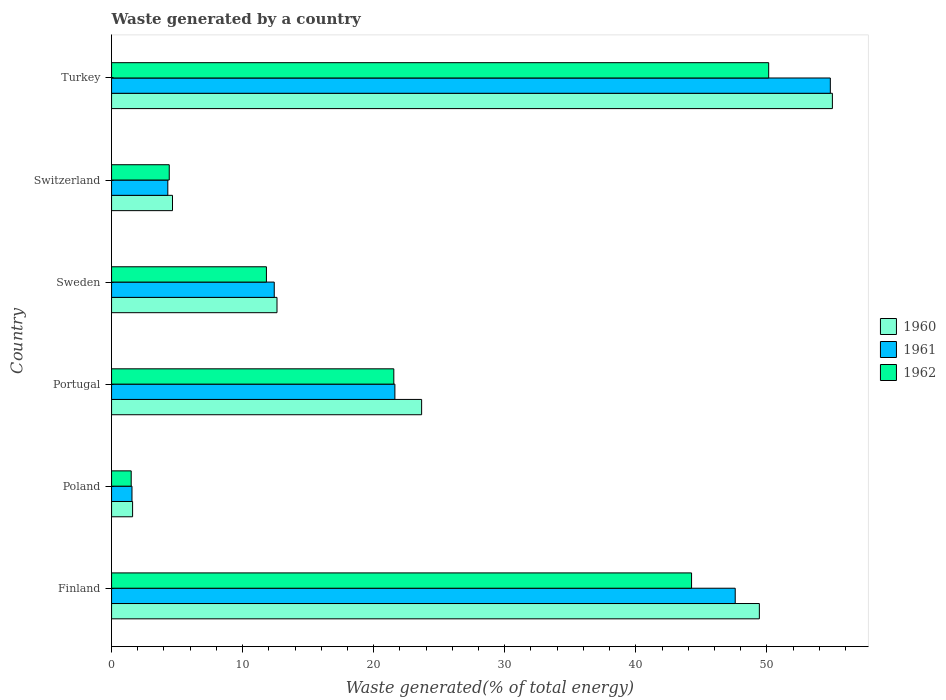How many groups of bars are there?
Offer a terse response. 6. Are the number of bars on each tick of the Y-axis equal?
Your response must be concise. Yes. How many bars are there on the 1st tick from the top?
Provide a short and direct response. 3. What is the label of the 2nd group of bars from the top?
Offer a terse response. Switzerland. In how many cases, is the number of bars for a given country not equal to the number of legend labels?
Provide a short and direct response. 0. What is the total waste generated in 1961 in Portugal?
Your response must be concise. 21.62. Across all countries, what is the maximum total waste generated in 1961?
Your response must be concise. 54.84. Across all countries, what is the minimum total waste generated in 1962?
Provide a short and direct response. 1.5. In which country was the total waste generated in 1962 maximum?
Make the answer very short. Turkey. In which country was the total waste generated in 1962 minimum?
Give a very brief answer. Poland. What is the total total waste generated in 1961 in the graph?
Provide a succinct answer. 142.3. What is the difference between the total waste generated in 1960 in Poland and that in Sweden?
Provide a succinct answer. -11.02. What is the difference between the total waste generated in 1960 in Turkey and the total waste generated in 1961 in Switzerland?
Your response must be concise. 50.7. What is the average total waste generated in 1962 per country?
Make the answer very short. 22.27. What is the difference between the total waste generated in 1961 and total waste generated in 1962 in Turkey?
Offer a terse response. 4.7. In how many countries, is the total waste generated in 1962 greater than 42 %?
Your response must be concise. 2. What is the ratio of the total waste generated in 1962 in Poland to that in Turkey?
Make the answer very short. 0.03. Is the difference between the total waste generated in 1961 in Switzerland and Turkey greater than the difference between the total waste generated in 1962 in Switzerland and Turkey?
Your response must be concise. No. What is the difference between the highest and the second highest total waste generated in 1960?
Your answer should be compact. 5.57. What is the difference between the highest and the lowest total waste generated in 1960?
Offer a terse response. 53.39. In how many countries, is the total waste generated in 1961 greater than the average total waste generated in 1961 taken over all countries?
Ensure brevity in your answer.  2. What does the 2nd bar from the top in Poland represents?
Offer a very short reply. 1961. What does the 3rd bar from the bottom in Portugal represents?
Your answer should be compact. 1962. Is it the case that in every country, the sum of the total waste generated in 1962 and total waste generated in 1961 is greater than the total waste generated in 1960?
Make the answer very short. Yes. Are all the bars in the graph horizontal?
Offer a very short reply. Yes. How many countries are there in the graph?
Provide a short and direct response. 6. What is the difference between two consecutive major ticks on the X-axis?
Provide a short and direct response. 10. Does the graph contain grids?
Give a very brief answer. No. Where does the legend appear in the graph?
Offer a very short reply. Center right. How many legend labels are there?
Offer a very short reply. 3. How are the legend labels stacked?
Keep it short and to the point. Vertical. What is the title of the graph?
Provide a succinct answer. Waste generated by a country. What is the label or title of the X-axis?
Your response must be concise. Waste generated(% of total energy). What is the label or title of the Y-axis?
Provide a succinct answer. Country. What is the Waste generated(% of total energy) of 1960 in Finland?
Offer a very short reply. 49.42. What is the Waste generated(% of total energy) in 1961 in Finland?
Keep it short and to the point. 47.58. What is the Waste generated(% of total energy) of 1962 in Finland?
Your answer should be compact. 44.25. What is the Waste generated(% of total energy) in 1960 in Poland?
Give a very brief answer. 1.6. What is the Waste generated(% of total energy) in 1961 in Poland?
Ensure brevity in your answer.  1.56. What is the Waste generated(% of total energy) in 1962 in Poland?
Your answer should be very brief. 1.5. What is the Waste generated(% of total energy) in 1960 in Portugal?
Provide a short and direct response. 23.66. What is the Waste generated(% of total energy) in 1961 in Portugal?
Offer a terse response. 21.62. What is the Waste generated(% of total energy) in 1962 in Portugal?
Your response must be concise. 21.53. What is the Waste generated(% of total energy) of 1960 in Sweden?
Ensure brevity in your answer.  12.62. What is the Waste generated(% of total energy) of 1961 in Sweden?
Offer a very short reply. 12.41. What is the Waste generated(% of total energy) in 1962 in Sweden?
Offer a very short reply. 11.82. What is the Waste generated(% of total energy) in 1960 in Switzerland?
Your answer should be very brief. 4.65. What is the Waste generated(% of total energy) of 1961 in Switzerland?
Your answer should be compact. 4.29. What is the Waste generated(% of total energy) of 1962 in Switzerland?
Your response must be concise. 4.4. What is the Waste generated(% of total energy) in 1960 in Turkey?
Ensure brevity in your answer.  54.99. What is the Waste generated(% of total energy) of 1961 in Turkey?
Make the answer very short. 54.84. What is the Waste generated(% of total energy) in 1962 in Turkey?
Your answer should be compact. 50.13. Across all countries, what is the maximum Waste generated(% of total energy) in 1960?
Offer a terse response. 54.99. Across all countries, what is the maximum Waste generated(% of total energy) of 1961?
Keep it short and to the point. 54.84. Across all countries, what is the maximum Waste generated(% of total energy) in 1962?
Keep it short and to the point. 50.13. Across all countries, what is the minimum Waste generated(% of total energy) of 1960?
Your response must be concise. 1.6. Across all countries, what is the minimum Waste generated(% of total energy) of 1961?
Keep it short and to the point. 1.56. Across all countries, what is the minimum Waste generated(% of total energy) in 1962?
Offer a very short reply. 1.5. What is the total Waste generated(% of total energy) of 1960 in the graph?
Ensure brevity in your answer.  146.95. What is the total Waste generated(% of total energy) of 1961 in the graph?
Your answer should be very brief. 142.3. What is the total Waste generated(% of total energy) in 1962 in the graph?
Your answer should be very brief. 133.64. What is the difference between the Waste generated(% of total energy) in 1960 in Finland and that in Poland?
Give a very brief answer. 47.82. What is the difference between the Waste generated(% of total energy) of 1961 in Finland and that in Poland?
Keep it short and to the point. 46.02. What is the difference between the Waste generated(% of total energy) of 1962 in Finland and that in Poland?
Provide a short and direct response. 42.75. What is the difference between the Waste generated(% of total energy) of 1960 in Finland and that in Portugal?
Keep it short and to the point. 25.77. What is the difference between the Waste generated(% of total energy) in 1961 in Finland and that in Portugal?
Your response must be concise. 25.96. What is the difference between the Waste generated(% of total energy) in 1962 in Finland and that in Portugal?
Ensure brevity in your answer.  22.72. What is the difference between the Waste generated(% of total energy) in 1960 in Finland and that in Sweden?
Provide a short and direct response. 36.8. What is the difference between the Waste generated(% of total energy) in 1961 in Finland and that in Sweden?
Offer a terse response. 35.17. What is the difference between the Waste generated(% of total energy) in 1962 in Finland and that in Sweden?
Give a very brief answer. 32.44. What is the difference between the Waste generated(% of total energy) in 1960 in Finland and that in Switzerland?
Make the answer very short. 44.77. What is the difference between the Waste generated(% of total energy) of 1961 in Finland and that in Switzerland?
Your answer should be very brief. 43.29. What is the difference between the Waste generated(% of total energy) in 1962 in Finland and that in Switzerland?
Provide a succinct answer. 39.85. What is the difference between the Waste generated(% of total energy) in 1960 in Finland and that in Turkey?
Make the answer very short. -5.57. What is the difference between the Waste generated(% of total energy) in 1961 in Finland and that in Turkey?
Offer a very short reply. -7.26. What is the difference between the Waste generated(% of total energy) of 1962 in Finland and that in Turkey?
Offer a terse response. -5.88. What is the difference between the Waste generated(% of total energy) of 1960 in Poland and that in Portugal?
Offer a terse response. -22.05. What is the difference between the Waste generated(% of total energy) of 1961 in Poland and that in Portugal?
Your answer should be very brief. -20.06. What is the difference between the Waste generated(% of total energy) of 1962 in Poland and that in Portugal?
Keep it short and to the point. -20.03. What is the difference between the Waste generated(% of total energy) of 1960 in Poland and that in Sweden?
Keep it short and to the point. -11.02. What is the difference between the Waste generated(% of total energy) of 1961 in Poland and that in Sweden?
Provide a succinct answer. -10.85. What is the difference between the Waste generated(% of total energy) in 1962 in Poland and that in Sweden?
Ensure brevity in your answer.  -10.32. What is the difference between the Waste generated(% of total energy) of 1960 in Poland and that in Switzerland?
Give a very brief answer. -3.04. What is the difference between the Waste generated(% of total energy) in 1961 in Poland and that in Switzerland?
Your answer should be very brief. -2.73. What is the difference between the Waste generated(% of total energy) of 1962 in Poland and that in Switzerland?
Give a very brief answer. -2.9. What is the difference between the Waste generated(% of total energy) of 1960 in Poland and that in Turkey?
Your answer should be compact. -53.39. What is the difference between the Waste generated(% of total energy) in 1961 in Poland and that in Turkey?
Your response must be concise. -53.28. What is the difference between the Waste generated(% of total energy) of 1962 in Poland and that in Turkey?
Make the answer very short. -48.64. What is the difference between the Waste generated(% of total energy) in 1960 in Portugal and that in Sweden?
Make the answer very short. 11.03. What is the difference between the Waste generated(% of total energy) in 1961 in Portugal and that in Sweden?
Your answer should be very brief. 9.2. What is the difference between the Waste generated(% of total energy) in 1962 in Portugal and that in Sweden?
Offer a very short reply. 9.72. What is the difference between the Waste generated(% of total energy) of 1960 in Portugal and that in Switzerland?
Your answer should be very brief. 19.01. What is the difference between the Waste generated(% of total energy) in 1961 in Portugal and that in Switzerland?
Provide a succinct answer. 17.32. What is the difference between the Waste generated(% of total energy) of 1962 in Portugal and that in Switzerland?
Ensure brevity in your answer.  17.13. What is the difference between the Waste generated(% of total energy) of 1960 in Portugal and that in Turkey?
Provide a short and direct response. -31.34. What is the difference between the Waste generated(% of total energy) of 1961 in Portugal and that in Turkey?
Offer a very short reply. -33.22. What is the difference between the Waste generated(% of total energy) in 1962 in Portugal and that in Turkey?
Your response must be concise. -28.6. What is the difference between the Waste generated(% of total energy) of 1960 in Sweden and that in Switzerland?
Give a very brief answer. 7.97. What is the difference between the Waste generated(% of total energy) in 1961 in Sweden and that in Switzerland?
Ensure brevity in your answer.  8.12. What is the difference between the Waste generated(% of total energy) of 1962 in Sweden and that in Switzerland?
Your response must be concise. 7.41. What is the difference between the Waste generated(% of total energy) in 1960 in Sweden and that in Turkey?
Your answer should be very brief. -42.37. What is the difference between the Waste generated(% of total energy) in 1961 in Sweden and that in Turkey?
Offer a terse response. -42.43. What is the difference between the Waste generated(% of total energy) in 1962 in Sweden and that in Turkey?
Your answer should be very brief. -38.32. What is the difference between the Waste generated(% of total energy) in 1960 in Switzerland and that in Turkey?
Ensure brevity in your answer.  -50.34. What is the difference between the Waste generated(% of total energy) in 1961 in Switzerland and that in Turkey?
Provide a short and direct response. -50.55. What is the difference between the Waste generated(% of total energy) in 1962 in Switzerland and that in Turkey?
Offer a terse response. -45.73. What is the difference between the Waste generated(% of total energy) in 1960 in Finland and the Waste generated(% of total energy) in 1961 in Poland?
Your response must be concise. 47.86. What is the difference between the Waste generated(% of total energy) in 1960 in Finland and the Waste generated(% of total energy) in 1962 in Poland?
Your answer should be very brief. 47.92. What is the difference between the Waste generated(% of total energy) in 1961 in Finland and the Waste generated(% of total energy) in 1962 in Poland?
Ensure brevity in your answer.  46.08. What is the difference between the Waste generated(% of total energy) of 1960 in Finland and the Waste generated(% of total energy) of 1961 in Portugal?
Your answer should be very brief. 27.81. What is the difference between the Waste generated(% of total energy) of 1960 in Finland and the Waste generated(% of total energy) of 1962 in Portugal?
Ensure brevity in your answer.  27.89. What is the difference between the Waste generated(% of total energy) of 1961 in Finland and the Waste generated(% of total energy) of 1962 in Portugal?
Your answer should be very brief. 26.05. What is the difference between the Waste generated(% of total energy) of 1960 in Finland and the Waste generated(% of total energy) of 1961 in Sweden?
Your answer should be compact. 37.01. What is the difference between the Waste generated(% of total energy) in 1960 in Finland and the Waste generated(% of total energy) in 1962 in Sweden?
Give a very brief answer. 37.61. What is the difference between the Waste generated(% of total energy) in 1961 in Finland and the Waste generated(% of total energy) in 1962 in Sweden?
Provide a short and direct response. 35.77. What is the difference between the Waste generated(% of total energy) of 1960 in Finland and the Waste generated(% of total energy) of 1961 in Switzerland?
Give a very brief answer. 45.13. What is the difference between the Waste generated(% of total energy) in 1960 in Finland and the Waste generated(% of total energy) in 1962 in Switzerland?
Offer a terse response. 45.02. What is the difference between the Waste generated(% of total energy) of 1961 in Finland and the Waste generated(% of total energy) of 1962 in Switzerland?
Your answer should be very brief. 43.18. What is the difference between the Waste generated(% of total energy) in 1960 in Finland and the Waste generated(% of total energy) in 1961 in Turkey?
Your answer should be very brief. -5.42. What is the difference between the Waste generated(% of total energy) in 1960 in Finland and the Waste generated(% of total energy) in 1962 in Turkey?
Keep it short and to the point. -0.71. What is the difference between the Waste generated(% of total energy) of 1961 in Finland and the Waste generated(% of total energy) of 1962 in Turkey?
Give a very brief answer. -2.55. What is the difference between the Waste generated(% of total energy) in 1960 in Poland and the Waste generated(% of total energy) in 1961 in Portugal?
Your response must be concise. -20.01. What is the difference between the Waste generated(% of total energy) of 1960 in Poland and the Waste generated(% of total energy) of 1962 in Portugal?
Make the answer very short. -19.93. What is the difference between the Waste generated(% of total energy) in 1961 in Poland and the Waste generated(% of total energy) in 1962 in Portugal?
Offer a very short reply. -19.98. What is the difference between the Waste generated(% of total energy) in 1960 in Poland and the Waste generated(% of total energy) in 1961 in Sweden?
Your answer should be compact. -10.81. What is the difference between the Waste generated(% of total energy) of 1960 in Poland and the Waste generated(% of total energy) of 1962 in Sweden?
Offer a very short reply. -10.21. What is the difference between the Waste generated(% of total energy) in 1961 in Poland and the Waste generated(% of total energy) in 1962 in Sweden?
Offer a very short reply. -10.26. What is the difference between the Waste generated(% of total energy) of 1960 in Poland and the Waste generated(% of total energy) of 1961 in Switzerland?
Provide a short and direct response. -2.69. What is the difference between the Waste generated(% of total energy) in 1960 in Poland and the Waste generated(% of total energy) in 1962 in Switzerland?
Ensure brevity in your answer.  -2.8. What is the difference between the Waste generated(% of total energy) of 1961 in Poland and the Waste generated(% of total energy) of 1962 in Switzerland?
Offer a very short reply. -2.84. What is the difference between the Waste generated(% of total energy) in 1960 in Poland and the Waste generated(% of total energy) in 1961 in Turkey?
Your answer should be very brief. -53.23. What is the difference between the Waste generated(% of total energy) of 1960 in Poland and the Waste generated(% of total energy) of 1962 in Turkey?
Ensure brevity in your answer.  -48.53. What is the difference between the Waste generated(% of total energy) of 1961 in Poland and the Waste generated(% of total energy) of 1962 in Turkey?
Offer a terse response. -48.58. What is the difference between the Waste generated(% of total energy) in 1960 in Portugal and the Waste generated(% of total energy) in 1961 in Sweden?
Provide a short and direct response. 11.24. What is the difference between the Waste generated(% of total energy) of 1960 in Portugal and the Waste generated(% of total energy) of 1962 in Sweden?
Offer a very short reply. 11.84. What is the difference between the Waste generated(% of total energy) of 1961 in Portugal and the Waste generated(% of total energy) of 1962 in Sweden?
Provide a succinct answer. 9.8. What is the difference between the Waste generated(% of total energy) of 1960 in Portugal and the Waste generated(% of total energy) of 1961 in Switzerland?
Give a very brief answer. 19.36. What is the difference between the Waste generated(% of total energy) of 1960 in Portugal and the Waste generated(% of total energy) of 1962 in Switzerland?
Keep it short and to the point. 19.25. What is the difference between the Waste generated(% of total energy) in 1961 in Portugal and the Waste generated(% of total energy) in 1962 in Switzerland?
Offer a very short reply. 17.21. What is the difference between the Waste generated(% of total energy) of 1960 in Portugal and the Waste generated(% of total energy) of 1961 in Turkey?
Offer a very short reply. -31.18. What is the difference between the Waste generated(% of total energy) of 1960 in Portugal and the Waste generated(% of total energy) of 1962 in Turkey?
Provide a short and direct response. -26.48. What is the difference between the Waste generated(% of total energy) of 1961 in Portugal and the Waste generated(% of total energy) of 1962 in Turkey?
Keep it short and to the point. -28.52. What is the difference between the Waste generated(% of total energy) in 1960 in Sweden and the Waste generated(% of total energy) in 1961 in Switzerland?
Give a very brief answer. 8.33. What is the difference between the Waste generated(% of total energy) of 1960 in Sweden and the Waste generated(% of total energy) of 1962 in Switzerland?
Keep it short and to the point. 8.22. What is the difference between the Waste generated(% of total energy) of 1961 in Sweden and the Waste generated(% of total energy) of 1962 in Switzerland?
Your answer should be very brief. 8.01. What is the difference between the Waste generated(% of total energy) of 1960 in Sweden and the Waste generated(% of total energy) of 1961 in Turkey?
Make the answer very short. -42.22. What is the difference between the Waste generated(% of total energy) of 1960 in Sweden and the Waste generated(% of total energy) of 1962 in Turkey?
Your answer should be compact. -37.51. What is the difference between the Waste generated(% of total energy) of 1961 in Sweden and the Waste generated(% of total energy) of 1962 in Turkey?
Make the answer very short. -37.72. What is the difference between the Waste generated(% of total energy) of 1960 in Switzerland and the Waste generated(% of total energy) of 1961 in Turkey?
Provide a succinct answer. -50.19. What is the difference between the Waste generated(% of total energy) of 1960 in Switzerland and the Waste generated(% of total energy) of 1962 in Turkey?
Your response must be concise. -45.48. What is the difference between the Waste generated(% of total energy) of 1961 in Switzerland and the Waste generated(% of total energy) of 1962 in Turkey?
Ensure brevity in your answer.  -45.84. What is the average Waste generated(% of total energy) of 1960 per country?
Your answer should be very brief. 24.49. What is the average Waste generated(% of total energy) of 1961 per country?
Keep it short and to the point. 23.72. What is the average Waste generated(% of total energy) in 1962 per country?
Offer a terse response. 22.27. What is the difference between the Waste generated(% of total energy) of 1960 and Waste generated(% of total energy) of 1961 in Finland?
Provide a succinct answer. 1.84. What is the difference between the Waste generated(% of total energy) of 1960 and Waste generated(% of total energy) of 1962 in Finland?
Your response must be concise. 5.17. What is the difference between the Waste generated(% of total energy) of 1961 and Waste generated(% of total energy) of 1962 in Finland?
Provide a succinct answer. 3.33. What is the difference between the Waste generated(% of total energy) in 1960 and Waste generated(% of total energy) in 1961 in Poland?
Offer a terse response. 0.05. What is the difference between the Waste generated(% of total energy) in 1960 and Waste generated(% of total energy) in 1962 in Poland?
Your answer should be compact. 0.11. What is the difference between the Waste generated(% of total energy) in 1961 and Waste generated(% of total energy) in 1962 in Poland?
Give a very brief answer. 0.06. What is the difference between the Waste generated(% of total energy) of 1960 and Waste generated(% of total energy) of 1961 in Portugal?
Offer a terse response. 2.04. What is the difference between the Waste generated(% of total energy) in 1960 and Waste generated(% of total energy) in 1962 in Portugal?
Give a very brief answer. 2.12. What is the difference between the Waste generated(% of total energy) of 1961 and Waste generated(% of total energy) of 1962 in Portugal?
Give a very brief answer. 0.08. What is the difference between the Waste generated(% of total energy) in 1960 and Waste generated(% of total energy) in 1961 in Sweden?
Your response must be concise. 0.21. What is the difference between the Waste generated(% of total energy) in 1960 and Waste generated(% of total energy) in 1962 in Sweden?
Provide a succinct answer. 0.81. What is the difference between the Waste generated(% of total energy) of 1961 and Waste generated(% of total energy) of 1962 in Sweden?
Keep it short and to the point. 0.6. What is the difference between the Waste generated(% of total energy) in 1960 and Waste generated(% of total energy) in 1961 in Switzerland?
Keep it short and to the point. 0.36. What is the difference between the Waste generated(% of total energy) in 1960 and Waste generated(% of total energy) in 1962 in Switzerland?
Your response must be concise. 0.25. What is the difference between the Waste generated(% of total energy) of 1961 and Waste generated(% of total energy) of 1962 in Switzerland?
Provide a short and direct response. -0.11. What is the difference between the Waste generated(% of total energy) in 1960 and Waste generated(% of total energy) in 1961 in Turkey?
Provide a succinct answer. 0.16. What is the difference between the Waste generated(% of total energy) in 1960 and Waste generated(% of total energy) in 1962 in Turkey?
Your response must be concise. 4.86. What is the difference between the Waste generated(% of total energy) in 1961 and Waste generated(% of total energy) in 1962 in Turkey?
Provide a succinct answer. 4.7. What is the ratio of the Waste generated(% of total energy) in 1960 in Finland to that in Poland?
Keep it short and to the point. 30.8. What is the ratio of the Waste generated(% of total energy) in 1961 in Finland to that in Poland?
Your answer should be compact. 30.53. What is the ratio of the Waste generated(% of total energy) in 1962 in Finland to that in Poland?
Ensure brevity in your answer.  29.52. What is the ratio of the Waste generated(% of total energy) in 1960 in Finland to that in Portugal?
Ensure brevity in your answer.  2.09. What is the ratio of the Waste generated(% of total energy) of 1961 in Finland to that in Portugal?
Give a very brief answer. 2.2. What is the ratio of the Waste generated(% of total energy) of 1962 in Finland to that in Portugal?
Offer a very short reply. 2.05. What is the ratio of the Waste generated(% of total energy) in 1960 in Finland to that in Sweden?
Keep it short and to the point. 3.92. What is the ratio of the Waste generated(% of total energy) of 1961 in Finland to that in Sweden?
Keep it short and to the point. 3.83. What is the ratio of the Waste generated(% of total energy) in 1962 in Finland to that in Sweden?
Your response must be concise. 3.75. What is the ratio of the Waste generated(% of total energy) in 1960 in Finland to that in Switzerland?
Offer a very short reply. 10.63. What is the ratio of the Waste generated(% of total energy) in 1961 in Finland to that in Switzerland?
Your answer should be compact. 11.09. What is the ratio of the Waste generated(% of total energy) of 1962 in Finland to that in Switzerland?
Offer a terse response. 10.05. What is the ratio of the Waste generated(% of total energy) in 1960 in Finland to that in Turkey?
Your answer should be compact. 0.9. What is the ratio of the Waste generated(% of total energy) of 1961 in Finland to that in Turkey?
Keep it short and to the point. 0.87. What is the ratio of the Waste generated(% of total energy) of 1962 in Finland to that in Turkey?
Your answer should be compact. 0.88. What is the ratio of the Waste generated(% of total energy) of 1960 in Poland to that in Portugal?
Give a very brief answer. 0.07. What is the ratio of the Waste generated(% of total energy) of 1961 in Poland to that in Portugal?
Ensure brevity in your answer.  0.07. What is the ratio of the Waste generated(% of total energy) of 1962 in Poland to that in Portugal?
Offer a very short reply. 0.07. What is the ratio of the Waste generated(% of total energy) in 1960 in Poland to that in Sweden?
Provide a succinct answer. 0.13. What is the ratio of the Waste generated(% of total energy) of 1961 in Poland to that in Sweden?
Provide a succinct answer. 0.13. What is the ratio of the Waste generated(% of total energy) in 1962 in Poland to that in Sweden?
Make the answer very short. 0.13. What is the ratio of the Waste generated(% of total energy) in 1960 in Poland to that in Switzerland?
Give a very brief answer. 0.35. What is the ratio of the Waste generated(% of total energy) in 1961 in Poland to that in Switzerland?
Ensure brevity in your answer.  0.36. What is the ratio of the Waste generated(% of total energy) of 1962 in Poland to that in Switzerland?
Provide a succinct answer. 0.34. What is the ratio of the Waste generated(% of total energy) of 1960 in Poland to that in Turkey?
Your answer should be compact. 0.03. What is the ratio of the Waste generated(% of total energy) of 1961 in Poland to that in Turkey?
Offer a terse response. 0.03. What is the ratio of the Waste generated(% of total energy) in 1962 in Poland to that in Turkey?
Provide a short and direct response. 0.03. What is the ratio of the Waste generated(% of total energy) of 1960 in Portugal to that in Sweden?
Ensure brevity in your answer.  1.87. What is the ratio of the Waste generated(% of total energy) of 1961 in Portugal to that in Sweden?
Provide a succinct answer. 1.74. What is the ratio of the Waste generated(% of total energy) in 1962 in Portugal to that in Sweden?
Ensure brevity in your answer.  1.82. What is the ratio of the Waste generated(% of total energy) of 1960 in Portugal to that in Switzerland?
Keep it short and to the point. 5.09. What is the ratio of the Waste generated(% of total energy) in 1961 in Portugal to that in Switzerland?
Provide a succinct answer. 5.04. What is the ratio of the Waste generated(% of total energy) in 1962 in Portugal to that in Switzerland?
Your answer should be compact. 4.89. What is the ratio of the Waste generated(% of total energy) of 1960 in Portugal to that in Turkey?
Offer a terse response. 0.43. What is the ratio of the Waste generated(% of total energy) in 1961 in Portugal to that in Turkey?
Provide a succinct answer. 0.39. What is the ratio of the Waste generated(% of total energy) in 1962 in Portugal to that in Turkey?
Ensure brevity in your answer.  0.43. What is the ratio of the Waste generated(% of total energy) in 1960 in Sweden to that in Switzerland?
Provide a short and direct response. 2.71. What is the ratio of the Waste generated(% of total energy) in 1961 in Sweden to that in Switzerland?
Keep it short and to the point. 2.89. What is the ratio of the Waste generated(% of total energy) of 1962 in Sweden to that in Switzerland?
Keep it short and to the point. 2.68. What is the ratio of the Waste generated(% of total energy) of 1960 in Sweden to that in Turkey?
Offer a very short reply. 0.23. What is the ratio of the Waste generated(% of total energy) in 1961 in Sweden to that in Turkey?
Ensure brevity in your answer.  0.23. What is the ratio of the Waste generated(% of total energy) of 1962 in Sweden to that in Turkey?
Your answer should be very brief. 0.24. What is the ratio of the Waste generated(% of total energy) in 1960 in Switzerland to that in Turkey?
Keep it short and to the point. 0.08. What is the ratio of the Waste generated(% of total energy) in 1961 in Switzerland to that in Turkey?
Make the answer very short. 0.08. What is the ratio of the Waste generated(% of total energy) of 1962 in Switzerland to that in Turkey?
Offer a terse response. 0.09. What is the difference between the highest and the second highest Waste generated(% of total energy) in 1960?
Your answer should be very brief. 5.57. What is the difference between the highest and the second highest Waste generated(% of total energy) of 1961?
Your answer should be very brief. 7.26. What is the difference between the highest and the second highest Waste generated(% of total energy) of 1962?
Your answer should be very brief. 5.88. What is the difference between the highest and the lowest Waste generated(% of total energy) in 1960?
Give a very brief answer. 53.39. What is the difference between the highest and the lowest Waste generated(% of total energy) of 1961?
Make the answer very short. 53.28. What is the difference between the highest and the lowest Waste generated(% of total energy) of 1962?
Provide a succinct answer. 48.64. 